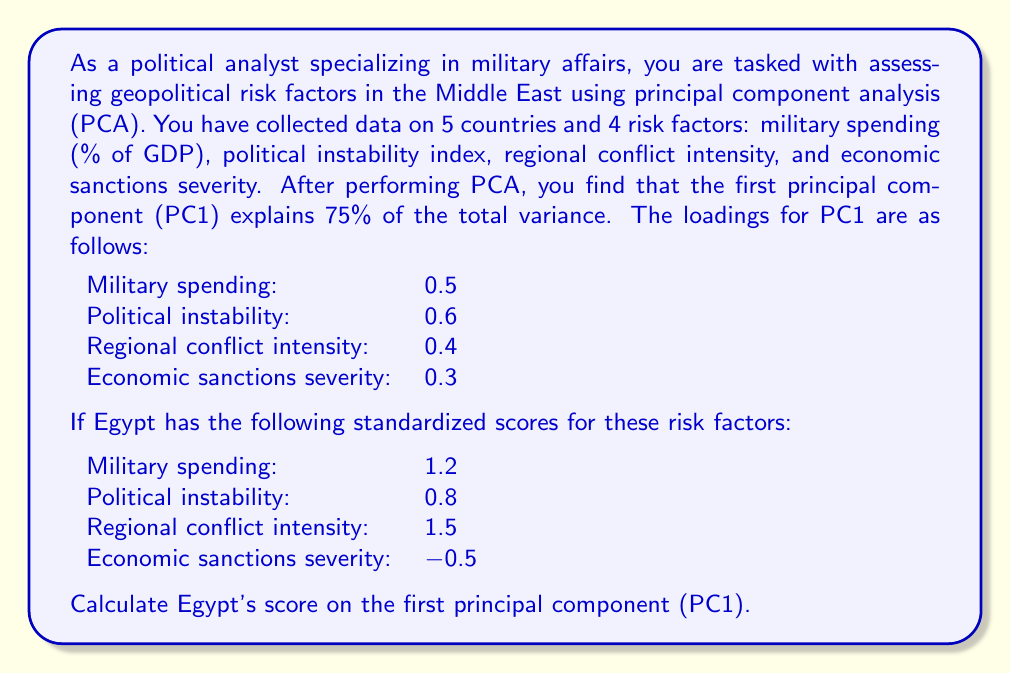Solve this math problem. To solve this problem, we need to understand the concept of principal component analysis (PCA) and how to calculate scores for a principal component.

1. Principal Component Analysis (PCA):
   PCA is a technique used to reduce the dimensionality of a dataset while retaining most of the variation. It creates new variables (principal components) that are linear combinations of the original variables.

2. Loadings:
   The loadings represent the weights of each original variable in the principal component. They indicate the importance of each variable in defining the component.

3. Calculating the score:
   To calculate a score on a principal component, we multiply each standardized variable by its corresponding loading and sum the results.

Let's calculate Egypt's score on PC1:

$$\text{PC1 Score} = \sum_{i=1}^{n} (\text{loading}_i \times \text{standardized score}_i)$$

Where $n$ is the number of variables (risk factors in this case).

Substituting the values:

$$\begin{align}
\text{PC1 Score} &= (0.5 \times 1.2) + (0.6 \times 0.8) + (0.4 \times 1.5) + (0.3 \times -0.5) \\
&= 0.6 + 0.48 + 0.6 - 0.15 \\
&= 1.53
\end{align}$$

This score represents Egypt's position along the first principal component, which captures the most significant pattern of variation in the geopolitical risk factors.
Answer: Egypt's score on the first principal component (PC1) is 1.53. 